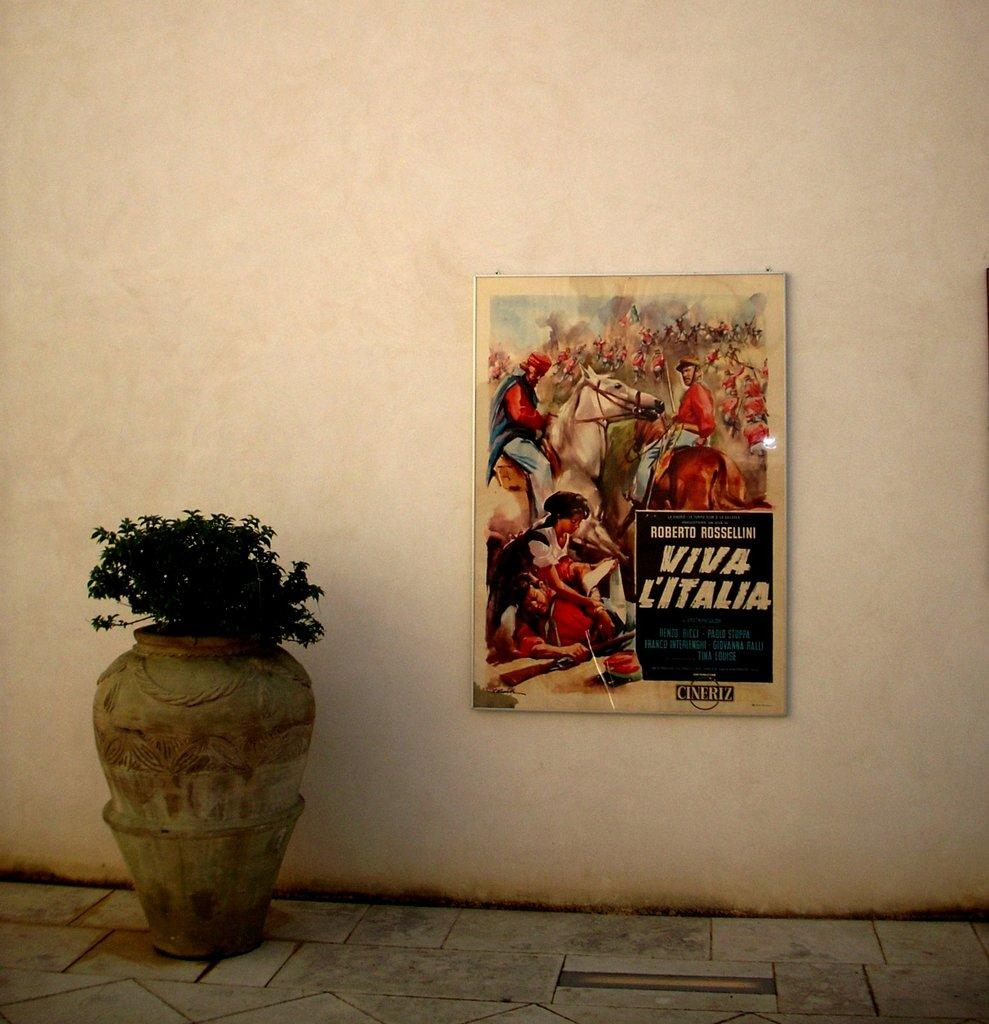What is inside the vase that is visible in the image? There is a plant in the vase that is visible in the image. What can be seen on the wall in the background of the image? There is a poster attached to the wall in the background of the image. Can you describe the feeling of the earth in the image? There is no reference to the earth or any feelings in the image, as it features a vase with a plant and a poster on the wall. 